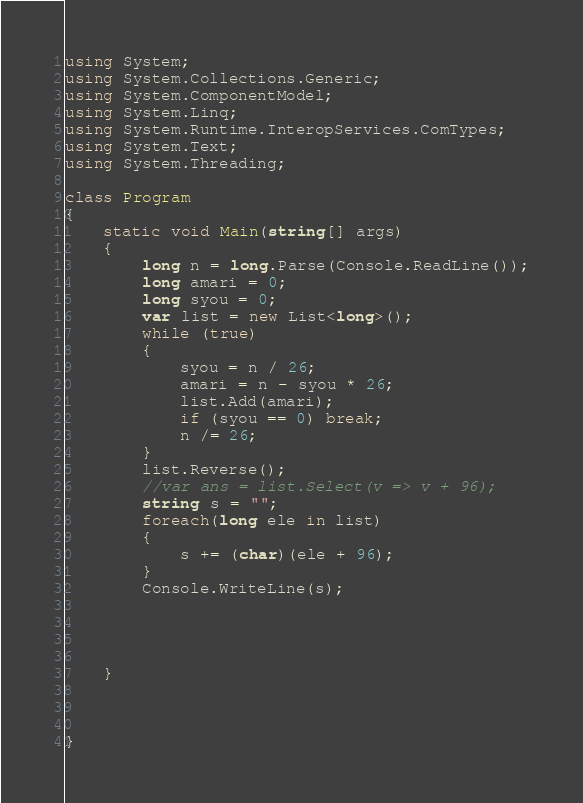Convert code to text. <code><loc_0><loc_0><loc_500><loc_500><_C#_>using System;
using System.Collections.Generic;
using System.ComponentModel;
using System.Linq;
using System.Runtime.InteropServices.ComTypes;
using System.Text;
using System.Threading;

class Program
{
    static void Main(string[] args)
    {
        long n = long.Parse(Console.ReadLine());
        long amari = 0;
        long syou = 0;
        var list = new List<long>();
        while (true)
        {
            syou = n / 26;
            amari = n - syou * 26;
            list.Add(amari);
            if (syou == 0) break;
            n /= 26;
        }
        list.Reverse();
        //var ans = list.Select(v => v + 96);
        string s = "";
        foreach(long ele in list)
        {
            s += (char)(ele + 96);
        }
        Console.WriteLine(s);
        
        
    
        
    }

    

}</code> 